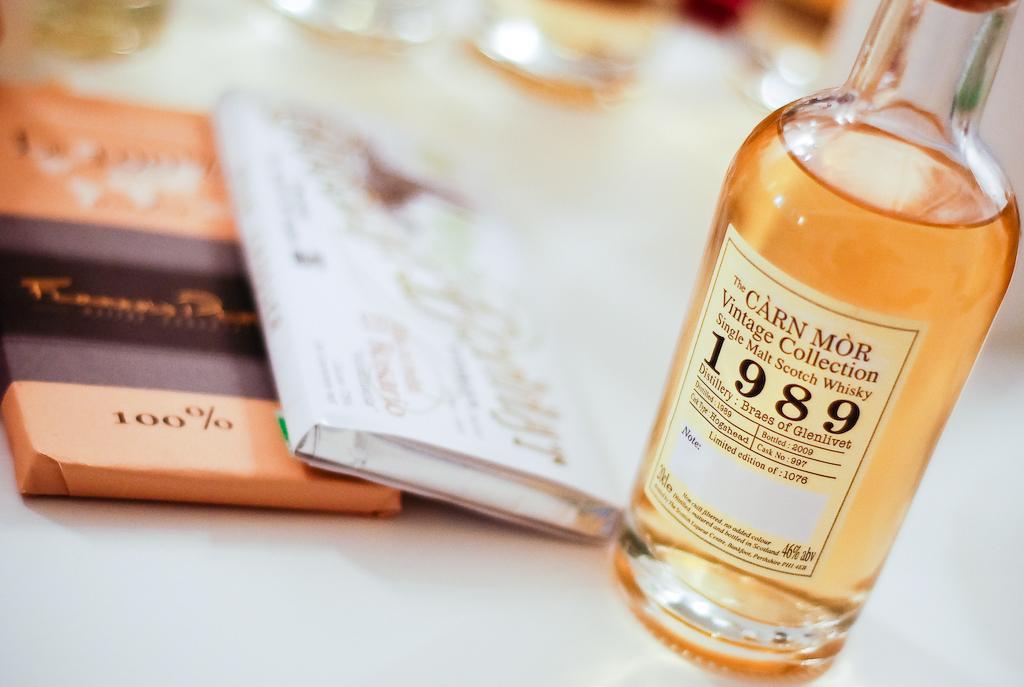Could you give a brief overview of what you see in this image? In this image i can see a table on the table there is a bottle contain a drink and there are some books kept on the table and there is a label attached to the bottle. 